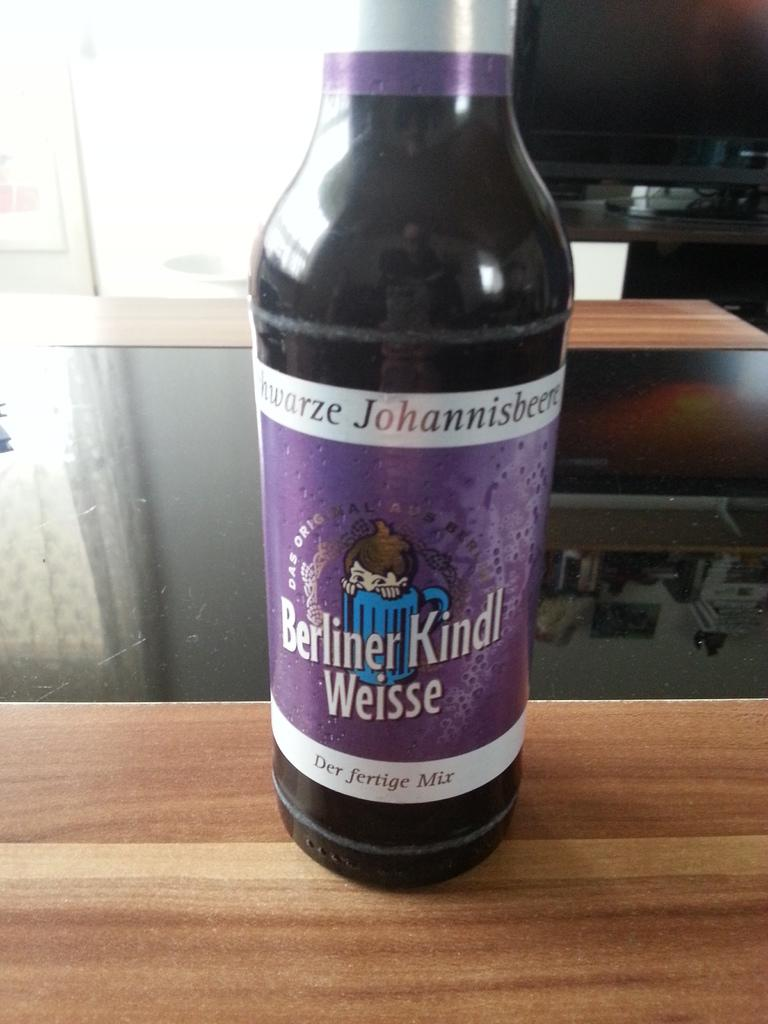<image>
Summarize the visual content of the image. a bottle of berliner kindl weisse der fertige mix 